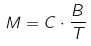Convert formula to latex. <formula><loc_0><loc_0><loc_500><loc_500>M = C \cdot \frac { B } { T }</formula> 